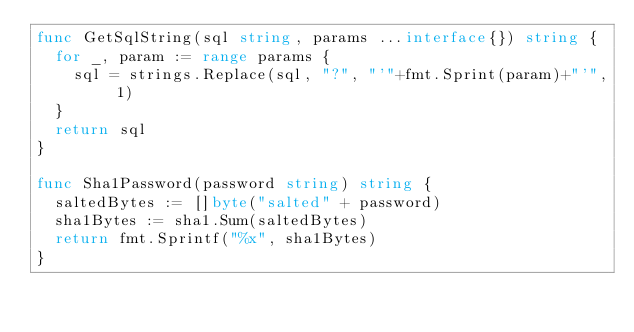Convert code to text. <code><loc_0><loc_0><loc_500><loc_500><_Go_>func GetSqlString(sql string, params ...interface{}) string {
	for _, param := range params {
		sql = strings.Replace(sql, "?", "'"+fmt.Sprint(param)+"'", 1)
	}
	return sql
}

func Sha1Password(password string) string {
	saltedBytes := []byte("salted" + password)
	sha1Bytes := sha1.Sum(saltedBytes)
	return fmt.Sprintf("%x", sha1Bytes)
}
</code> 